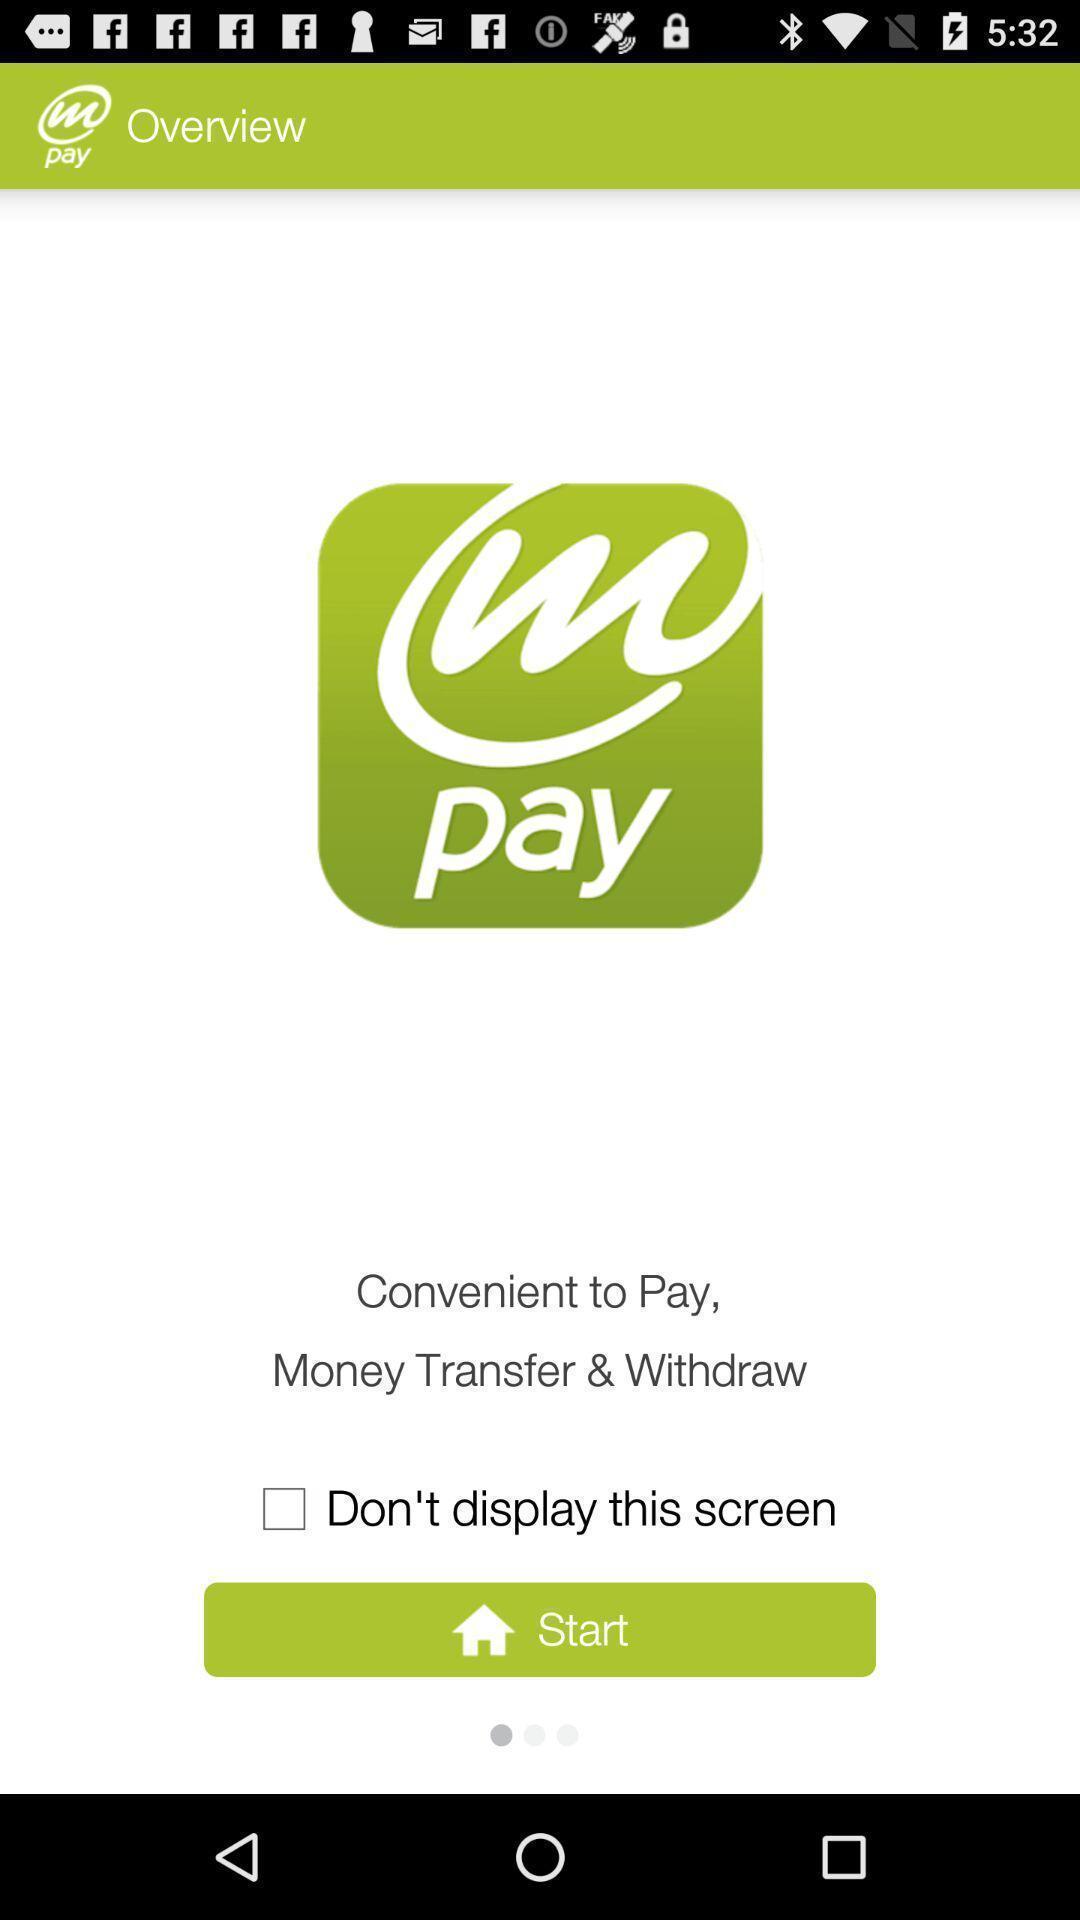Describe the key features of this screenshot. Welcome page. 